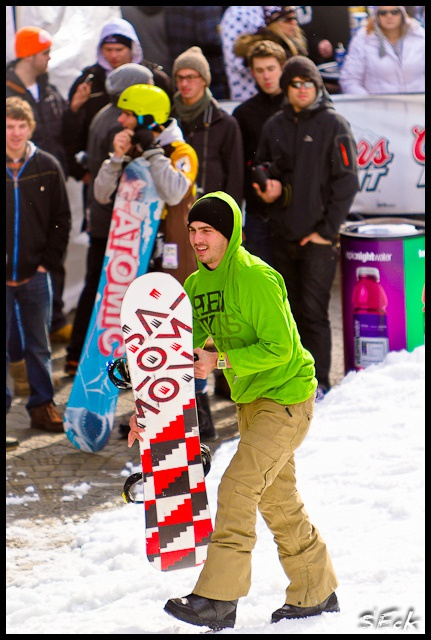Describe the objects in this image and their specific colors. I can see people in black, green, and tan tones, snowboard in black, white, red, gray, and maroon tones, people in black, lightpink, darkgray, and maroon tones, people in black, gray, and maroon tones, and people in black, navy, gray, and brown tones in this image. 